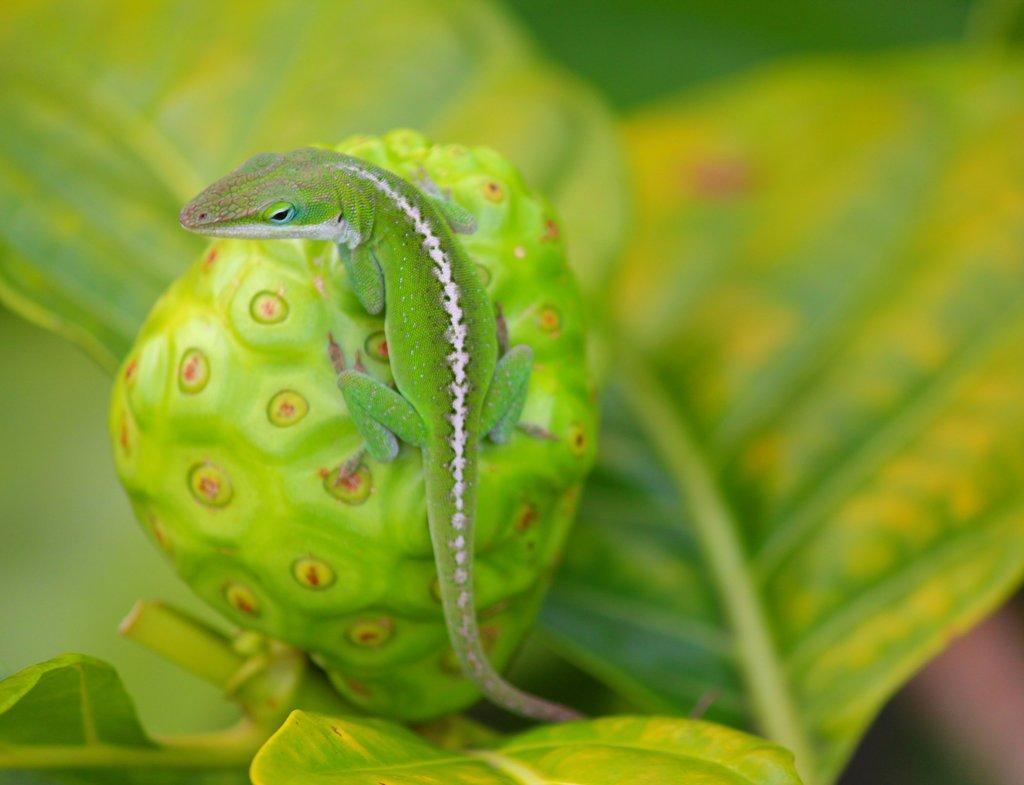What type of animal can be seen in the image? There is a lizard in the image. Where is the lizard located in the image? The lizard is on the bud of a flower. Can you describe the background of the image? The background of the image is blurry. What type of window can be seen in the image? There is no window present in the image. 